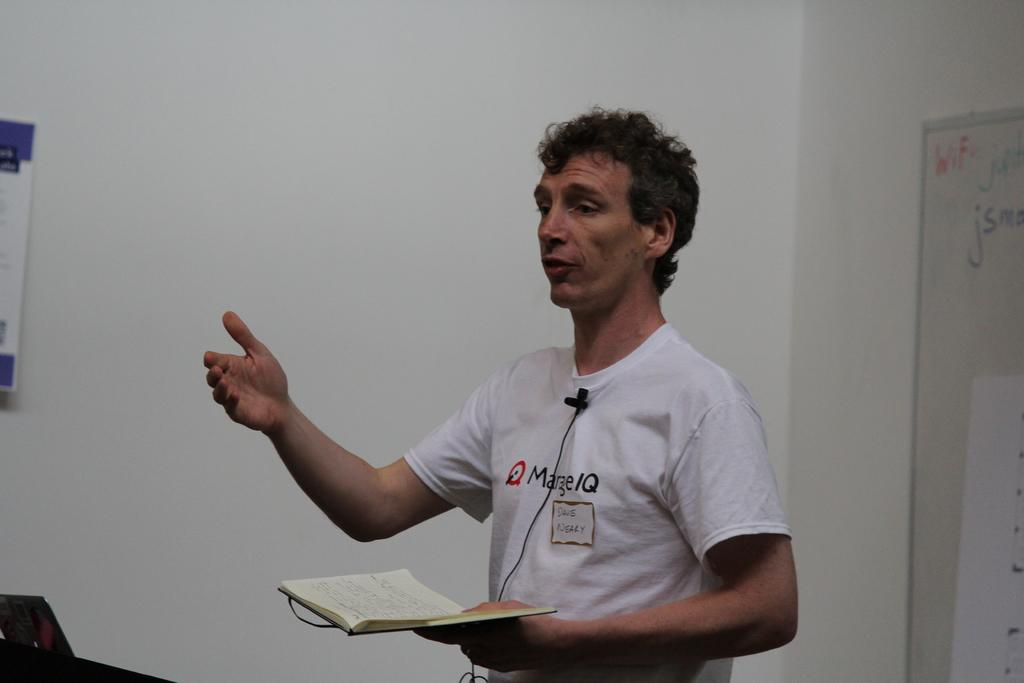<image>
Render a clear and concise summary of the photo. a man in a white shirt presenting something with the letters IQ on his shirt 